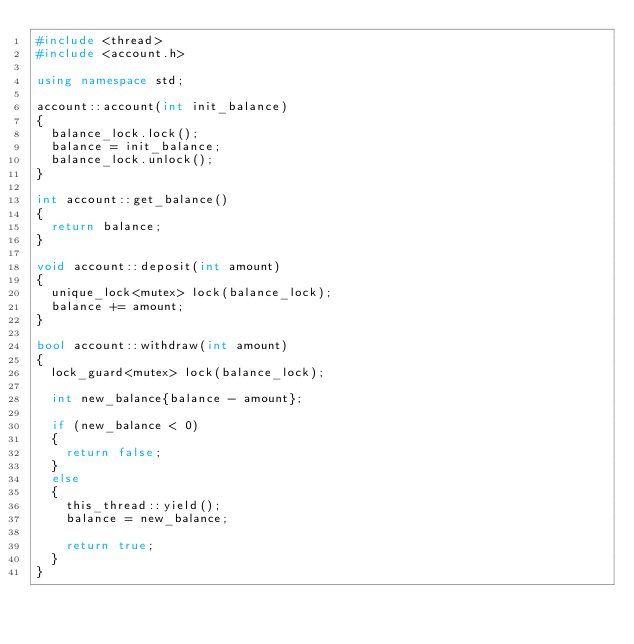Convert code to text. <code><loc_0><loc_0><loc_500><loc_500><_C++_>#include <thread>
#include <account.h>

using namespace std;

account::account(int init_balance)
{
  balance_lock.lock();
  balance = init_balance;
  balance_lock.unlock();
}

int account::get_balance()
{
  return balance;
}

void account::deposit(int amount)
{
  unique_lock<mutex> lock(balance_lock);
  balance += amount;
}

bool account::withdraw(int amount)
{
  lock_guard<mutex> lock(balance_lock);

  int new_balance{balance - amount};

  if (new_balance < 0)
  {
    return false;
  }
  else
  {
    this_thread::yield();
    balance = new_balance;

    return true;
  }
}</code> 